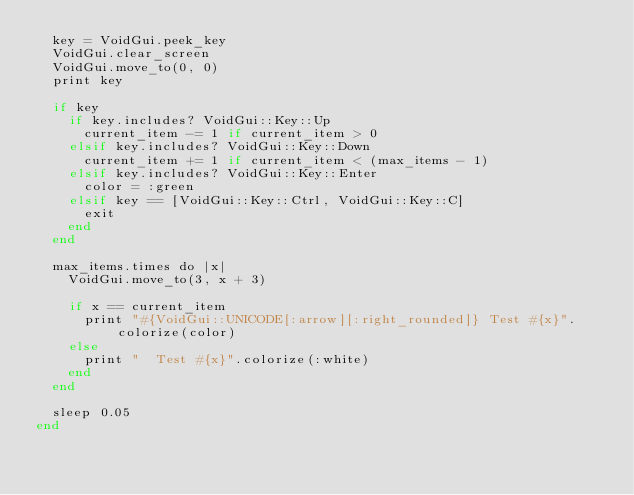<code> <loc_0><loc_0><loc_500><loc_500><_Crystal_>  key = VoidGui.peek_key
  VoidGui.clear_screen
  VoidGui.move_to(0, 0)
  print key

  if key
    if key.includes? VoidGui::Key::Up
      current_item -= 1 if current_item > 0
    elsif key.includes? VoidGui::Key::Down
      current_item += 1 if current_item < (max_items - 1)
    elsif key.includes? VoidGui::Key::Enter
      color = :green
    elsif key == [VoidGui::Key::Ctrl, VoidGui::Key::C]
      exit
    end
  end

  max_items.times do |x|
    VoidGui.move_to(3, x + 3)

    if x == current_item
      print "#{VoidGui::UNICODE[:arrow][:right_rounded]} Test #{x}".colorize(color)
    else
      print "  Test #{x}".colorize(:white)
    end
  end

  sleep 0.05
end
</code> 